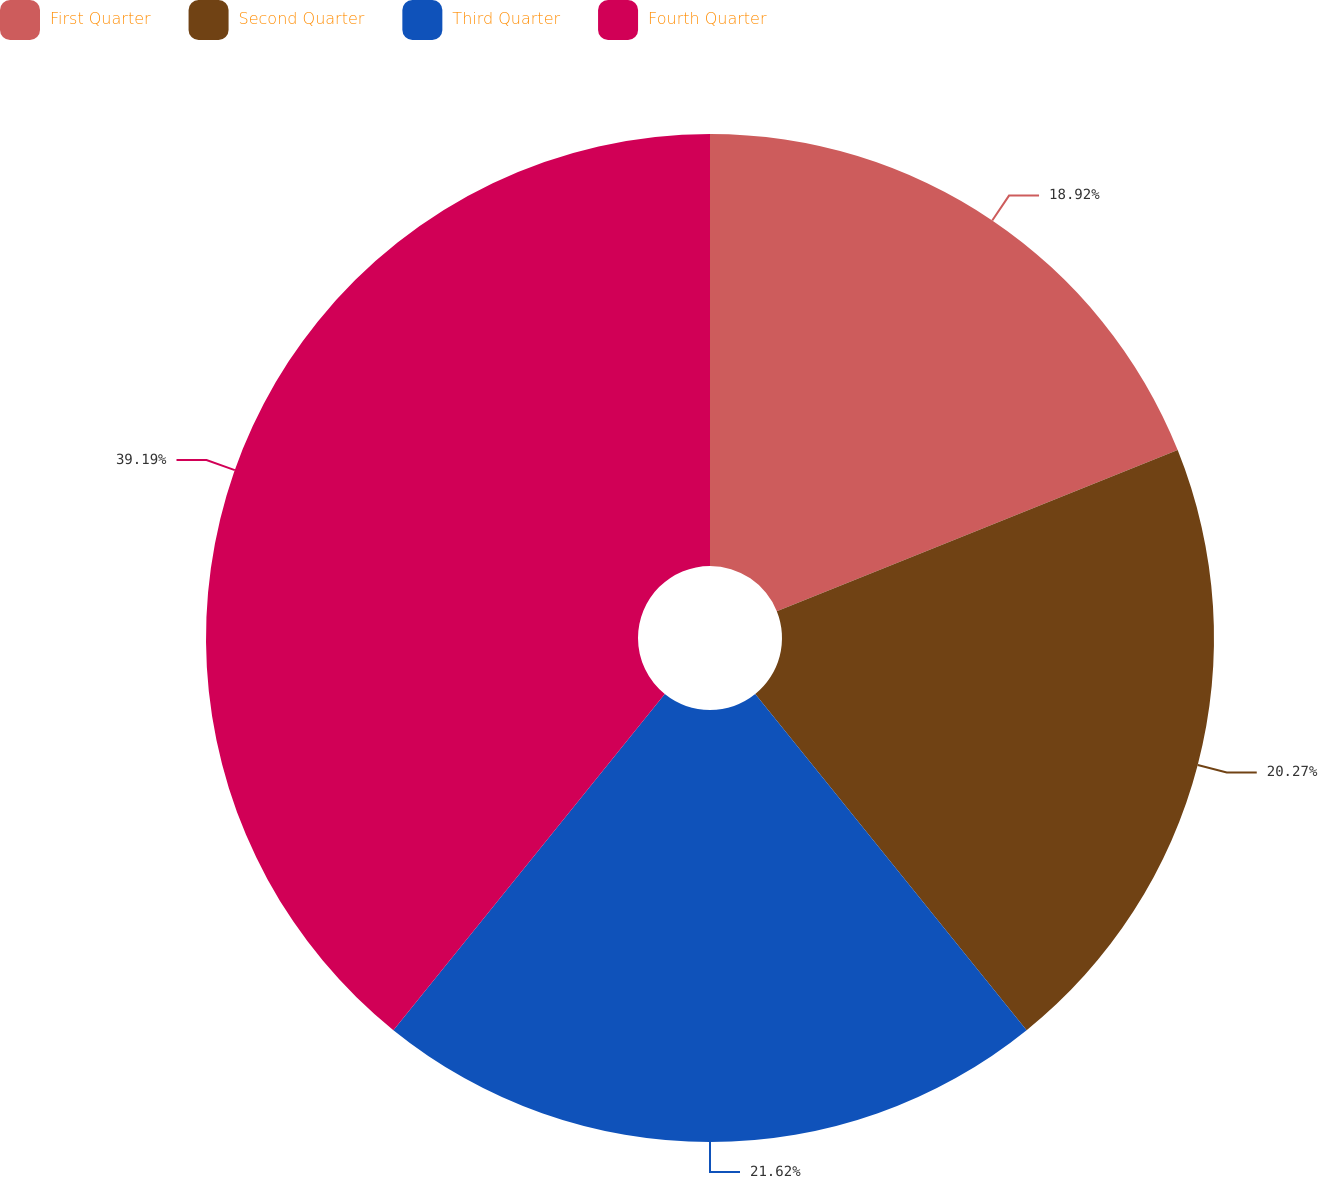<chart> <loc_0><loc_0><loc_500><loc_500><pie_chart><fcel>First Quarter<fcel>Second Quarter<fcel>Third Quarter<fcel>Fourth Quarter<nl><fcel>18.92%<fcel>20.27%<fcel>21.62%<fcel>39.19%<nl></chart> 